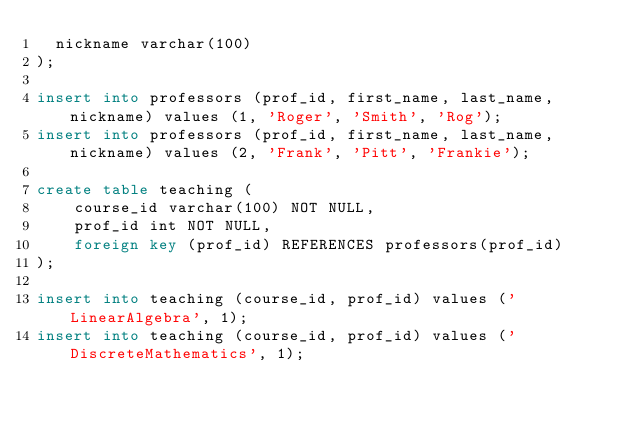Convert code to text. <code><loc_0><loc_0><loc_500><loc_500><_SQL_>  nickname varchar(100)
);

insert into professors (prof_id, first_name, last_name, nickname) values (1, 'Roger', 'Smith', 'Rog');
insert into professors (prof_id, first_name, last_name, nickname) values (2, 'Frank', 'Pitt', 'Frankie');

create table teaching (
	course_id varchar(100) NOT NULL,
	prof_id int NOT NULL,
	foreign key (prof_id) REFERENCES professors(prof_id)
);

insert into teaching (course_id, prof_id) values ('LinearAlgebra', 1);
insert into teaching (course_id, prof_id) values ('DiscreteMathematics', 1);
</code> 